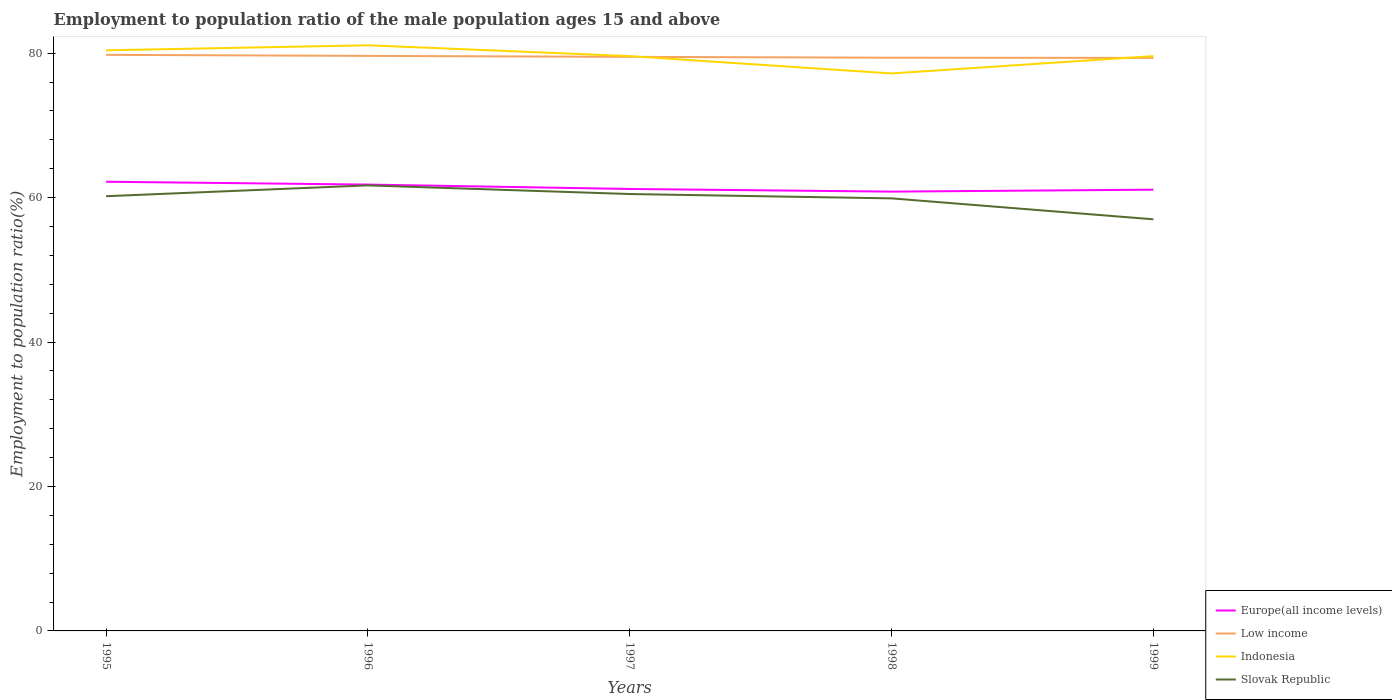How many different coloured lines are there?
Your answer should be very brief. 4. Does the line corresponding to Slovak Republic intersect with the line corresponding to Indonesia?
Make the answer very short. No. Across all years, what is the maximum employment to population ratio in Europe(all income levels)?
Your response must be concise. 60.83. What is the total employment to population ratio in Low income in the graph?
Offer a terse response. 0.39. What is the difference between the highest and the second highest employment to population ratio in Slovak Republic?
Your answer should be very brief. 4.7. What is the difference between the highest and the lowest employment to population ratio in Slovak Republic?
Keep it short and to the point. 4. How many lines are there?
Offer a very short reply. 4. What is the difference between two consecutive major ticks on the Y-axis?
Your answer should be very brief. 20. Does the graph contain grids?
Keep it short and to the point. No. Where does the legend appear in the graph?
Offer a terse response. Bottom right. How many legend labels are there?
Ensure brevity in your answer.  4. How are the legend labels stacked?
Your answer should be very brief. Vertical. What is the title of the graph?
Offer a terse response. Employment to population ratio of the male population ages 15 and above. What is the Employment to population ratio(%) of Europe(all income levels) in 1995?
Give a very brief answer. 62.2. What is the Employment to population ratio(%) of Low income in 1995?
Keep it short and to the point. 79.77. What is the Employment to population ratio(%) of Indonesia in 1995?
Keep it short and to the point. 80.4. What is the Employment to population ratio(%) of Slovak Republic in 1995?
Offer a terse response. 60.2. What is the Employment to population ratio(%) in Europe(all income levels) in 1996?
Your response must be concise. 61.81. What is the Employment to population ratio(%) of Low income in 1996?
Give a very brief answer. 79.63. What is the Employment to population ratio(%) in Indonesia in 1996?
Ensure brevity in your answer.  81.1. What is the Employment to population ratio(%) of Slovak Republic in 1996?
Your answer should be compact. 61.7. What is the Employment to population ratio(%) of Europe(all income levels) in 1997?
Your answer should be very brief. 61.2. What is the Employment to population ratio(%) in Low income in 1997?
Keep it short and to the point. 79.5. What is the Employment to population ratio(%) in Indonesia in 1997?
Make the answer very short. 79.6. What is the Employment to population ratio(%) in Slovak Republic in 1997?
Your answer should be very brief. 60.5. What is the Employment to population ratio(%) of Europe(all income levels) in 1998?
Give a very brief answer. 60.83. What is the Employment to population ratio(%) of Low income in 1998?
Provide a succinct answer. 79.38. What is the Employment to population ratio(%) in Indonesia in 1998?
Provide a succinct answer. 77.2. What is the Employment to population ratio(%) of Slovak Republic in 1998?
Your response must be concise. 59.9. What is the Employment to population ratio(%) in Europe(all income levels) in 1999?
Make the answer very short. 61.1. What is the Employment to population ratio(%) of Low income in 1999?
Offer a terse response. 79.35. What is the Employment to population ratio(%) of Indonesia in 1999?
Make the answer very short. 79.6. What is the Employment to population ratio(%) in Slovak Republic in 1999?
Your answer should be very brief. 57. Across all years, what is the maximum Employment to population ratio(%) in Europe(all income levels)?
Your answer should be very brief. 62.2. Across all years, what is the maximum Employment to population ratio(%) of Low income?
Offer a terse response. 79.77. Across all years, what is the maximum Employment to population ratio(%) of Indonesia?
Make the answer very short. 81.1. Across all years, what is the maximum Employment to population ratio(%) in Slovak Republic?
Give a very brief answer. 61.7. Across all years, what is the minimum Employment to population ratio(%) in Europe(all income levels)?
Make the answer very short. 60.83. Across all years, what is the minimum Employment to population ratio(%) in Low income?
Offer a very short reply. 79.35. Across all years, what is the minimum Employment to population ratio(%) of Indonesia?
Offer a very short reply. 77.2. Across all years, what is the minimum Employment to population ratio(%) in Slovak Republic?
Provide a succinct answer. 57. What is the total Employment to population ratio(%) of Europe(all income levels) in the graph?
Provide a succinct answer. 307.15. What is the total Employment to population ratio(%) in Low income in the graph?
Make the answer very short. 397.63. What is the total Employment to population ratio(%) in Indonesia in the graph?
Give a very brief answer. 397.9. What is the total Employment to population ratio(%) of Slovak Republic in the graph?
Offer a very short reply. 299.3. What is the difference between the Employment to population ratio(%) of Europe(all income levels) in 1995 and that in 1996?
Provide a succinct answer. 0.39. What is the difference between the Employment to population ratio(%) of Low income in 1995 and that in 1996?
Ensure brevity in your answer.  0.14. What is the difference between the Employment to population ratio(%) in Indonesia in 1995 and that in 1996?
Your response must be concise. -0.7. What is the difference between the Employment to population ratio(%) of Europe(all income levels) in 1995 and that in 1997?
Your response must be concise. 1. What is the difference between the Employment to population ratio(%) of Low income in 1995 and that in 1997?
Your answer should be compact. 0.28. What is the difference between the Employment to population ratio(%) of Europe(all income levels) in 1995 and that in 1998?
Your answer should be very brief. 1.37. What is the difference between the Employment to population ratio(%) of Low income in 1995 and that in 1998?
Keep it short and to the point. 0.39. What is the difference between the Employment to population ratio(%) of Indonesia in 1995 and that in 1998?
Offer a terse response. 3.2. What is the difference between the Employment to population ratio(%) in Europe(all income levels) in 1995 and that in 1999?
Keep it short and to the point. 1.1. What is the difference between the Employment to population ratio(%) in Low income in 1995 and that in 1999?
Give a very brief answer. 0.42. What is the difference between the Employment to population ratio(%) of Slovak Republic in 1995 and that in 1999?
Keep it short and to the point. 3.2. What is the difference between the Employment to population ratio(%) of Europe(all income levels) in 1996 and that in 1997?
Ensure brevity in your answer.  0.61. What is the difference between the Employment to population ratio(%) in Low income in 1996 and that in 1997?
Give a very brief answer. 0.13. What is the difference between the Employment to population ratio(%) in Europe(all income levels) in 1996 and that in 1998?
Your response must be concise. 0.97. What is the difference between the Employment to population ratio(%) of Low income in 1996 and that in 1998?
Keep it short and to the point. 0.25. What is the difference between the Employment to population ratio(%) in Indonesia in 1996 and that in 1998?
Your answer should be compact. 3.9. What is the difference between the Employment to population ratio(%) of Slovak Republic in 1996 and that in 1998?
Give a very brief answer. 1.8. What is the difference between the Employment to population ratio(%) of Europe(all income levels) in 1996 and that in 1999?
Offer a very short reply. 0.71. What is the difference between the Employment to population ratio(%) in Low income in 1996 and that in 1999?
Ensure brevity in your answer.  0.28. What is the difference between the Employment to population ratio(%) in Europe(all income levels) in 1997 and that in 1998?
Provide a succinct answer. 0.37. What is the difference between the Employment to population ratio(%) of Low income in 1997 and that in 1998?
Provide a short and direct response. 0.12. What is the difference between the Employment to population ratio(%) in Slovak Republic in 1997 and that in 1998?
Keep it short and to the point. 0.6. What is the difference between the Employment to population ratio(%) of Europe(all income levels) in 1997 and that in 1999?
Provide a short and direct response. 0.1. What is the difference between the Employment to population ratio(%) in Low income in 1997 and that in 1999?
Offer a terse response. 0.14. What is the difference between the Employment to population ratio(%) of Slovak Republic in 1997 and that in 1999?
Your response must be concise. 3.5. What is the difference between the Employment to population ratio(%) in Europe(all income levels) in 1998 and that in 1999?
Your answer should be very brief. -0.27. What is the difference between the Employment to population ratio(%) in Low income in 1998 and that in 1999?
Offer a terse response. 0.03. What is the difference between the Employment to population ratio(%) of Europe(all income levels) in 1995 and the Employment to population ratio(%) of Low income in 1996?
Ensure brevity in your answer.  -17.43. What is the difference between the Employment to population ratio(%) of Europe(all income levels) in 1995 and the Employment to population ratio(%) of Indonesia in 1996?
Your answer should be compact. -18.9. What is the difference between the Employment to population ratio(%) in Europe(all income levels) in 1995 and the Employment to population ratio(%) in Slovak Republic in 1996?
Your response must be concise. 0.5. What is the difference between the Employment to population ratio(%) in Low income in 1995 and the Employment to population ratio(%) in Indonesia in 1996?
Your answer should be compact. -1.33. What is the difference between the Employment to population ratio(%) in Low income in 1995 and the Employment to population ratio(%) in Slovak Republic in 1996?
Provide a succinct answer. 18.07. What is the difference between the Employment to population ratio(%) of Indonesia in 1995 and the Employment to population ratio(%) of Slovak Republic in 1996?
Make the answer very short. 18.7. What is the difference between the Employment to population ratio(%) in Europe(all income levels) in 1995 and the Employment to population ratio(%) in Low income in 1997?
Your answer should be very brief. -17.29. What is the difference between the Employment to population ratio(%) in Europe(all income levels) in 1995 and the Employment to population ratio(%) in Indonesia in 1997?
Give a very brief answer. -17.4. What is the difference between the Employment to population ratio(%) in Europe(all income levels) in 1995 and the Employment to population ratio(%) in Slovak Republic in 1997?
Your answer should be very brief. 1.7. What is the difference between the Employment to population ratio(%) of Low income in 1995 and the Employment to population ratio(%) of Indonesia in 1997?
Provide a short and direct response. 0.17. What is the difference between the Employment to population ratio(%) of Low income in 1995 and the Employment to population ratio(%) of Slovak Republic in 1997?
Offer a terse response. 19.27. What is the difference between the Employment to population ratio(%) of Europe(all income levels) in 1995 and the Employment to population ratio(%) of Low income in 1998?
Offer a terse response. -17.18. What is the difference between the Employment to population ratio(%) in Europe(all income levels) in 1995 and the Employment to population ratio(%) in Indonesia in 1998?
Ensure brevity in your answer.  -15. What is the difference between the Employment to population ratio(%) in Europe(all income levels) in 1995 and the Employment to population ratio(%) in Slovak Republic in 1998?
Offer a terse response. 2.3. What is the difference between the Employment to population ratio(%) of Low income in 1995 and the Employment to population ratio(%) of Indonesia in 1998?
Give a very brief answer. 2.57. What is the difference between the Employment to population ratio(%) of Low income in 1995 and the Employment to population ratio(%) of Slovak Republic in 1998?
Offer a very short reply. 19.87. What is the difference between the Employment to population ratio(%) of Indonesia in 1995 and the Employment to population ratio(%) of Slovak Republic in 1998?
Make the answer very short. 20.5. What is the difference between the Employment to population ratio(%) in Europe(all income levels) in 1995 and the Employment to population ratio(%) in Low income in 1999?
Ensure brevity in your answer.  -17.15. What is the difference between the Employment to population ratio(%) of Europe(all income levels) in 1995 and the Employment to population ratio(%) of Indonesia in 1999?
Your answer should be compact. -17.4. What is the difference between the Employment to population ratio(%) of Europe(all income levels) in 1995 and the Employment to population ratio(%) of Slovak Republic in 1999?
Keep it short and to the point. 5.2. What is the difference between the Employment to population ratio(%) of Low income in 1995 and the Employment to population ratio(%) of Indonesia in 1999?
Ensure brevity in your answer.  0.17. What is the difference between the Employment to population ratio(%) of Low income in 1995 and the Employment to population ratio(%) of Slovak Republic in 1999?
Your response must be concise. 22.77. What is the difference between the Employment to population ratio(%) of Indonesia in 1995 and the Employment to population ratio(%) of Slovak Republic in 1999?
Your response must be concise. 23.4. What is the difference between the Employment to population ratio(%) in Europe(all income levels) in 1996 and the Employment to population ratio(%) in Low income in 1997?
Ensure brevity in your answer.  -17.69. What is the difference between the Employment to population ratio(%) of Europe(all income levels) in 1996 and the Employment to population ratio(%) of Indonesia in 1997?
Ensure brevity in your answer.  -17.79. What is the difference between the Employment to population ratio(%) in Europe(all income levels) in 1996 and the Employment to population ratio(%) in Slovak Republic in 1997?
Keep it short and to the point. 1.31. What is the difference between the Employment to population ratio(%) in Low income in 1996 and the Employment to population ratio(%) in Indonesia in 1997?
Your answer should be compact. 0.03. What is the difference between the Employment to population ratio(%) of Low income in 1996 and the Employment to population ratio(%) of Slovak Republic in 1997?
Provide a short and direct response. 19.13. What is the difference between the Employment to population ratio(%) in Indonesia in 1996 and the Employment to population ratio(%) in Slovak Republic in 1997?
Provide a short and direct response. 20.6. What is the difference between the Employment to population ratio(%) of Europe(all income levels) in 1996 and the Employment to population ratio(%) of Low income in 1998?
Your answer should be very brief. -17.57. What is the difference between the Employment to population ratio(%) of Europe(all income levels) in 1996 and the Employment to population ratio(%) of Indonesia in 1998?
Offer a very short reply. -15.39. What is the difference between the Employment to population ratio(%) in Europe(all income levels) in 1996 and the Employment to population ratio(%) in Slovak Republic in 1998?
Provide a succinct answer. 1.91. What is the difference between the Employment to population ratio(%) of Low income in 1996 and the Employment to population ratio(%) of Indonesia in 1998?
Offer a terse response. 2.43. What is the difference between the Employment to population ratio(%) in Low income in 1996 and the Employment to population ratio(%) in Slovak Republic in 1998?
Give a very brief answer. 19.73. What is the difference between the Employment to population ratio(%) of Indonesia in 1996 and the Employment to population ratio(%) of Slovak Republic in 1998?
Offer a terse response. 21.2. What is the difference between the Employment to population ratio(%) in Europe(all income levels) in 1996 and the Employment to population ratio(%) in Low income in 1999?
Your response must be concise. -17.54. What is the difference between the Employment to population ratio(%) in Europe(all income levels) in 1996 and the Employment to population ratio(%) in Indonesia in 1999?
Offer a very short reply. -17.79. What is the difference between the Employment to population ratio(%) in Europe(all income levels) in 1996 and the Employment to population ratio(%) in Slovak Republic in 1999?
Make the answer very short. 4.81. What is the difference between the Employment to population ratio(%) of Low income in 1996 and the Employment to population ratio(%) of Indonesia in 1999?
Make the answer very short. 0.03. What is the difference between the Employment to population ratio(%) in Low income in 1996 and the Employment to population ratio(%) in Slovak Republic in 1999?
Your response must be concise. 22.63. What is the difference between the Employment to population ratio(%) in Indonesia in 1996 and the Employment to population ratio(%) in Slovak Republic in 1999?
Offer a very short reply. 24.1. What is the difference between the Employment to population ratio(%) of Europe(all income levels) in 1997 and the Employment to population ratio(%) of Low income in 1998?
Your answer should be very brief. -18.18. What is the difference between the Employment to population ratio(%) of Europe(all income levels) in 1997 and the Employment to population ratio(%) of Indonesia in 1998?
Your answer should be compact. -16. What is the difference between the Employment to population ratio(%) in Europe(all income levels) in 1997 and the Employment to population ratio(%) in Slovak Republic in 1998?
Offer a very short reply. 1.3. What is the difference between the Employment to population ratio(%) of Low income in 1997 and the Employment to population ratio(%) of Indonesia in 1998?
Ensure brevity in your answer.  2.3. What is the difference between the Employment to population ratio(%) in Low income in 1997 and the Employment to population ratio(%) in Slovak Republic in 1998?
Ensure brevity in your answer.  19.6. What is the difference between the Employment to population ratio(%) of Europe(all income levels) in 1997 and the Employment to population ratio(%) of Low income in 1999?
Offer a terse response. -18.15. What is the difference between the Employment to population ratio(%) of Europe(all income levels) in 1997 and the Employment to population ratio(%) of Indonesia in 1999?
Ensure brevity in your answer.  -18.4. What is the difference between the Employment to population ratio(%) in Europe(all income levels) in 1997 and the Employment to population ratio(%) in Slovak Republic in 1999?
Your response must be concise. 4.2. What is the difference between the Employment to population ratio(%) of Low income in 1997 and the Employment to population ratio(%) of Indonesia in 1999?
Provide a short and direct response. -0.1. What is the difference between the Employment to population ratio(%) of Low income in 1997 and the Employment to population ratio(%) of Slovak Republic in 1999?
Give a very brief answer. 22.5. What is the difference between the Employment to population ratio(%) in Indonesia in 1997 and the Employment to population ratio(%) in Slovak Republic in 1999?
Offer a terse response. 22.6. What is the difference between the Employment to population ratio(%) in Europe(all income levels) in 1998 and the Employment to population ratio(%) in Low income in 1999?
Your response must be concise. -18.52. What is the difference between the Employment to population ratio(%) in Europe(all income levels) in 1998 and the Employment to population ratio(%) in Indonesia in 1999?
Offer a terse response. -18.77. What is the difference between the Employment to population ratio(%) of Europe(all income levels) in 1998 and the Employment to population ratio(%) of Slovak Republic in 1999?
Give a very brief answer. 3.83. What is the difference between the Employment to population ratio(%) of Low income in 1998 and the Employment to population ratio(%) of Indonesia in 1999?
Make the answer very short. -0.22. What is the difference between the Employment to population ratio(%) in Low income in 1998 and the Employment to population ratio(%) in Slovak Republic in 1999?
Keep it short and to the point. 22.38. What is the difference between the Employment to population ratio(%) in Indonesia in 1998 and the Employment to population ratio(%) in Slovak Republic in 1999?
Your answer should be very brief. 20.2. What is the average Employment to population ratio(%) in Europe(all income levels) per year?
Keep it short and to the point. 61.43. What is the average Employment to population ratio(%) in Low income per year?
Your answer should be compact. 79.53. What is the average Employment to population ratio(%) in Indonesia per year?
Provide a succinct answer. 79.58. What is the average Employment to population ratio(%) in Slovak Republic per year?
Ensure brevity in your answer.  59.86. In the year 1995, what is the difference between the Employment to population ratio(%) in Europe(all income levels) and Employment to population ratio(%) in Low income?
Offer a very short reply. -17.57. In the year 1995, what is the difference between the Employment to population ratio(%) in Europe(all income levels) and Employment to population ratio(%) in Indonesia?
Your answer should be very brief. -18.2. In the year 1995, what is the difference between the Employment to population ratio(%) in Europe(all income levels) and Employment to population ratio(%) in Slovak Republic?
Provide a succinct answer. 2. In the year 1995, what is the difference between the Employment to population ratio(%) in Low income and Employment to population ratio(%) in Indonesia?
Provide a succinct answer. -0.63. In the year 1995, what is the difference between the Employment to population ratio(%) of Low income and Employment to population ratio(%) of Slovak Republic?
Make the answer very short. 19.57. In the year 1995, what is the difference between the Employment to population ratio(%) in Indonesia and Employment to population ratio(%) in Slovak Republic?
Provide a short and direct response. 20.2. In the year 1996, what is the difference between the Employment to population ratio(%) of Europe(all income levels) and Employment to population ratio(%) of Low income?
Your answer should be compact. -17.82. In the year 1996, what is the difference between the Employment to population ratio(%) of Europe(all income levels) and Employment to population ratio(%) of Indonesia?
Your answer should be very brief. -19.29. In the year 1996, what is the difference between the Employment to population ratio(%) in Europe(all income levels) and Employment to population ratio(%) in Slovak Republic?
Give a very brief answer. 0.11. In the year 1996, what is the difference between the Employment to population ratio(%) in Low income and Employment to population ratio(%) in Indonesia?
Offer a very short reply. -1.47. In the year 1996, what is the difference between the Employment to population ratio(%) in Low income and Employment to population ratio(%) in Slovak Republic?
Your answer should be very brief. 17.93. In the year 1996, what is the difference between the Employment to population ratio(%) in Indonesia and Employment to population ratio(%) in Slovak Republic?
Ensure brevity in your answer.  19.4. In the year 1997, what is the difference between the Employment to population ratio(%) in Europe(all income levels) and Employment to population ratio(%) in Low income?
Offer a very short reply. -18.29. In the year 1997, what is the difference between the Employment to population ratio(%) of Europe(all income levels) and Employment to population ratio(%) of Indonesia?
Keep it short and to the point. -18.4. In the year 1997, what is the difference between the Employment to population ratio(%) of Europe(all income levels) and Employment to population ratio(%) of Slovak Republic?
Your answer should be compact. 0.7. In the year 1997, what is the difference between the Employment to population ratio(%) in Low income and Employment to population ratio(%) in Indonesia?
Your response must be concise. -0.1. In the year 1997, what is the difference between the Employment to population ratio(%) of Low income and Employment to population ratio(%) of Slovak Republic?
Your answer should be compact. 19. In the year 1998, what is the difference between the Employment to population ratio(%) of Europe(all income levels) and Employment to population ratio(%) of Low income?
Give a very brief answer. -18.54. In the year 1998, what is the difference between the Employment to population ratio(%) in Europe(all income levels) and Employment to population ratio(%) in Indonesia?
Give a very brief answer. -16.37. In the year 1998, what is the difference between the Employment to population ratio(%) in Europe(all income levels) and Employment to population ratio(%) in Slovak Republic?
Offer a very short reply. 0.93. In the year 1998, what is the difference between the Employment to population ratio(%) in Low income and Employment to population ratio(%) in Indonesia?
Offer a very short reply. 2.18. In the year 1998, what is the difference between the Employment to population ratio(%) in Low income and Employment to population ratio(%) in Slovak Republic?
Make the answer very short. 19.48. In the year 1998, what is the difference between the Employment to population ratio(%) in Indonesia and Employment to population ratio(%) in Slovak Republic?
Make the answer very short. 17.3. In the year 1999, what is the difference between the Employment to population ratio(%) of Europe(all income levels) and Employment to population ratio(%) of Low income?
Your answer should be compact. -18.25. In the year 1999, what is the difference between the Employment to population ratio(%) of Europe(all income levels) and Employment to population ratio(%) of Indonesia?
Give a very brief answer. -18.5. In the year 1999, what is the difference between the Employment to population ratio(%) of Europe(all income levels) and Employment to population ratio(%) of Slovak Republic?
Your answer should be compact. 4.1. In the year 1999, what is the difference between the Employment to population ratio(%) of Low income and Employment to population ratio(%) of Indonesia?
Make the answer very short. -0.25. In the year 1999, what is the difference between the Employment to population ratio(%) of Low income and Employment to population ratio(%) of Slovak Republic?
Offer a very short reply. 22.35. In the year 1999, what is the difference between the Employment to population ratio(%) in Indonesia and Employment to population ratio(%) in Slovak Republic?
Your answer should be very brief. 22.6. What is the ratio of the Employment to population ratio(%) in Europe(all income levels) in 1995 to that in 1996?
Provide a short and direct response. 1.01. What is the ratio of the Employment to population ratio(%) in Indonesia in 1995 to that in 1996?
Your response must be concise. 0.99. What is the ratio of the Employment to population ratio(%) of Slovak Republic in 1995 to that in 1996?
Your answer should be very brief. 0.98. What is the ratio of the Employment to population ratio(%) of Europe(all income levels) in 1995 to that in 1997?
Your response must be concise. 1.02. What is the ratio of the Employment to population ratio(%) in Low income in 1995 to that in 1997?
Offer a terse response. 1. What is the ratio of the Employment to population ratio(%) of Indonesia in 1995 to that in 1997?
Offer a very short reply. 1.01. What is the ratio of the Employment to population ratio(%) in Europe(all income levels) in 1995 to that in 1998?
Provide a succinct answer. 1.02. What is the ratio of the Employment to population ratio(%) in Indonesia in 1995 to that in 1998?
Keep it short and to the point. 1.04. What is the ratio of the Employment to population ratio(%) in Low income in 1995 to that in 1999?
Ensure brevity in your answer.  1.01. What is the ratio of the Employment to population ratio(%) in Indonesia in 1995 to that in 1999?
Your answer should be compact. 1.01. What is the ratio of the Employment to population ratio(%) of Slovak Republic in 1995 to that in 1999?
Offer a very short reply. 1.06. What is the ratio of the Employment to population ratio(%) of Europe(all income levels) in 1996 to that in 1997?
Ensure brevity in your answer.  1.01. What is the ratio of the Employment to population ratio(%) of Indonesia in 1996 to that in 1997?
Ensure brevity in your answer.  1.02. What is the ratio of the Employment to population ratio(%) in Slovak Republic in 1996 to that in 1997?
Offer a terse response. 1.02. What is the ratio of the Employment to population ratio(%) in Europe(all income levels) in 1996 to that in 1998?
Your response must be concise. 1.02. What is the ratio of the Employment to population ratio(%) in Indonesia in 1996 to that in 1998?
Your answer should be compact. 1.05. What is the ratio of the Employment to population ratio(%) in Slovak Republic in 1996 to that in 1998?
Offer a terse response. 1.03. What is the ratio of the Employment to population ratio(%) in Europe(all income levels) in 1996 to that in 1999?
Make the answer very short. 1.01. What is the ratio of the Employment to population ratio(%) of Indonesia in 1996 to that in 1999?
Keep it short and to the point. 1.02. What is the ratio of the Employment to population ratio(%) in Slovak Republic in 1996 to that in 1999?
Keep it short and to the point. 1.08. What is the ratio of the Employment to population ratio(%) of Indonesia in 1997 to that in 1998?
Make the answer very short. 1.03. What is the ratio of the Employment to population ratio(%) of Slovak Republic in 1997 to that in 1998?
Offer a terse response. 1.01. What is the ratio of the Employment to population ratio(%) in Europe(all income levels) in 1997 to that in 1999?
Keep it short and to the point. 1. What is the ratio of the Employment to population ratio(%) in Low income in 1997 to that in 1999?
Keep it short and to the point. 1. What is the ratio of the Employment to population ratio(%) in Indonesia in 1997 to that in 1999?
Offer a very short reply. 1. What is the ratio of the Employment to population ratio(%) in Slovak Republic in 1997 to that in 1999?
Provide a short and direct response. 1.06. What is the ratio of the Employment to population ratio(%) of Europe(all income levels) in 1998 to that in 1999?
Offer a very short reply. 1. What is the ratio of the Employment to population ratio(%) in Low income in 1998 to that in 1999?
Provide a short and direct response. 1. What is the ratio of the Employment to population ratio(%) in Indonesia in 1998 to that in 1999?
Your answer should be compact. 0.97. What is the ratio of the Employment to population ratio(%) of Slovak Republic in 1998 to that in 1999?
Offer a very short reply. 1.05. What is the difference between the highest and the second highest Employment to population ratio(%) of Europe(all income levels)?
Make the answer very short. 0.39. What is the difference between the highest and the second highest Employment to population ratio(%) of Low income?
Your response must be concise. 0.14. What is the difference between the highest and the second highest Employment to population ratio(%) of Indonesia?
Your response must be concise. 0.7. What is the difference between the highest and the second highest Employment to population ratio(%) of Slovak Republic?
Ensure brevity in your answer.  1.2. What is the difference between the highest and the lowest Employment to population ratio(%) in Europe(all income levels)?
Keep it short and to the point. 1.37. What is the difference between the highest and the lowest Employment to population ratio(%) of Low income?
Offer a very short reply. 0.42. What is the difference between the highest and the lowest Employment to population ratio(%) of Slovak Republic?
Your answer should be compact. 4.7. 